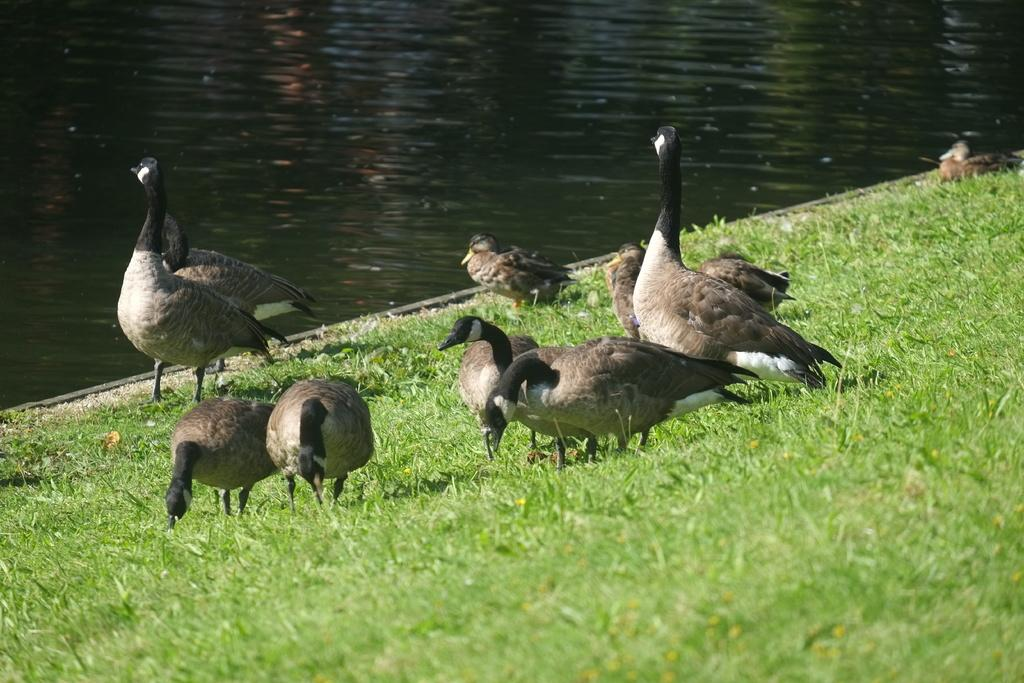What type of vegetation is present in the image? There is grass in the image. What animals can be seen in the image? There are birds in the image. What natural element is visible in the image? There is water visible in the image. What type of skin condition can be seen on the birds in the image? There is no mention of any skin condition on the birds in the image. In fact, there are no birds with skin in the image, as birds have feathers, not skin. 